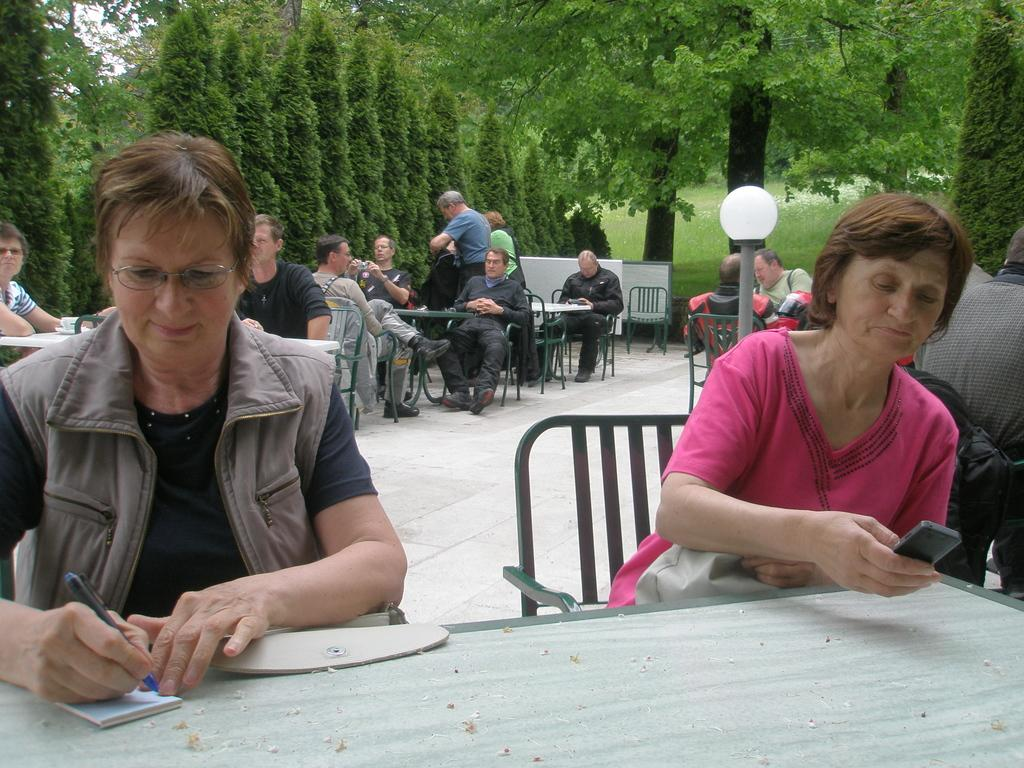What is the lady in the image wearing? There is a lady wearing a jacket in the image. What is the lady doing with the book? The lady is writing something on a book. Can you describe the other lady in the image? There is a pink color dress wearing lady in the image. What is the lady holding in her hand? The lady is holding a mobile. What is the lady sitting on? The lady is sitting on a chair. Can you tell me how many crates are visible in the image? There are no crates present in the image. What type of roll can be seen being prepared by the lady in the image? There is no roll being prepared by the lady in the image. 